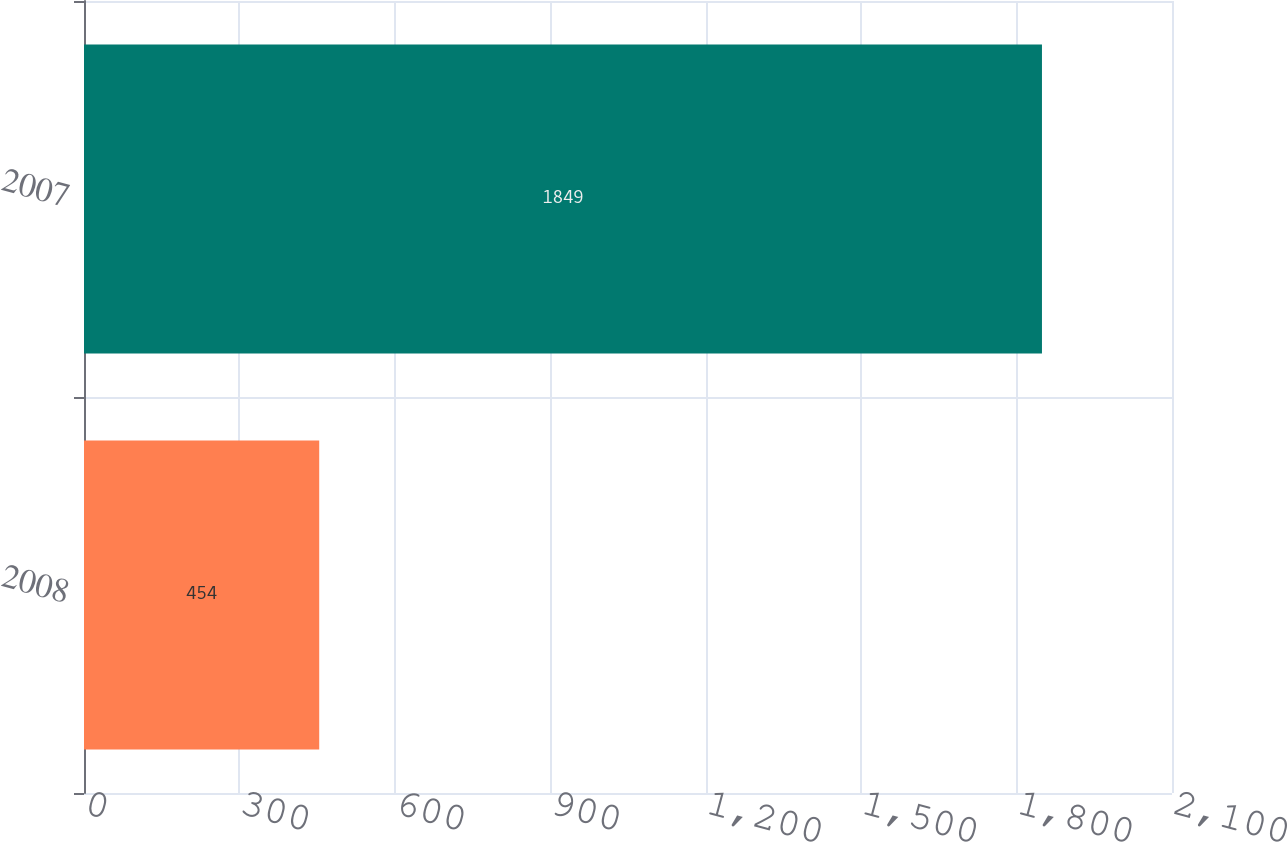<chart> <loc_0><loc_0><loc_500><loc_500><bar_chart><fcel>2008<fcel>2007<nl><fcel>454<fcel>1849<nl></chart> 